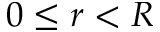<formula> <loc_0><loc_0><loc_500><loc_500>0 \leq r < R</formula> 